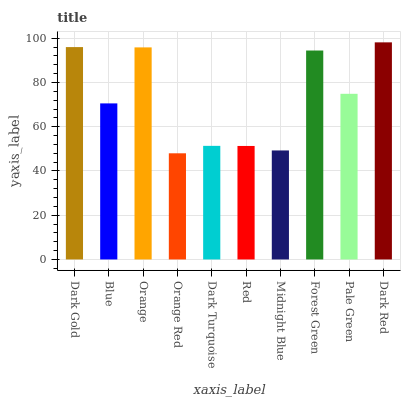Is Blue the minimum?
Answer yes or no. No. Is Blue the maximum?
Answer yes or no. No. Is Dark Gold greater than Blue?
Answer yes or no. Yes. Is Blue less than Dark Gold?
Answer yes or no. Yes. Is Blue greater than Dark Gold?
Answer yes or no. No. Is Dark Gold less than Blue?
Answer yes or no. No. Is Pale Green the high median?
Answer yes or no. Yes. Is Blue the low median?
Answer yes or no. Yes. Is Dark Red the high median?
Answer yes or no. No. Is Orange Red the low median?
Answer yes or no. No. 